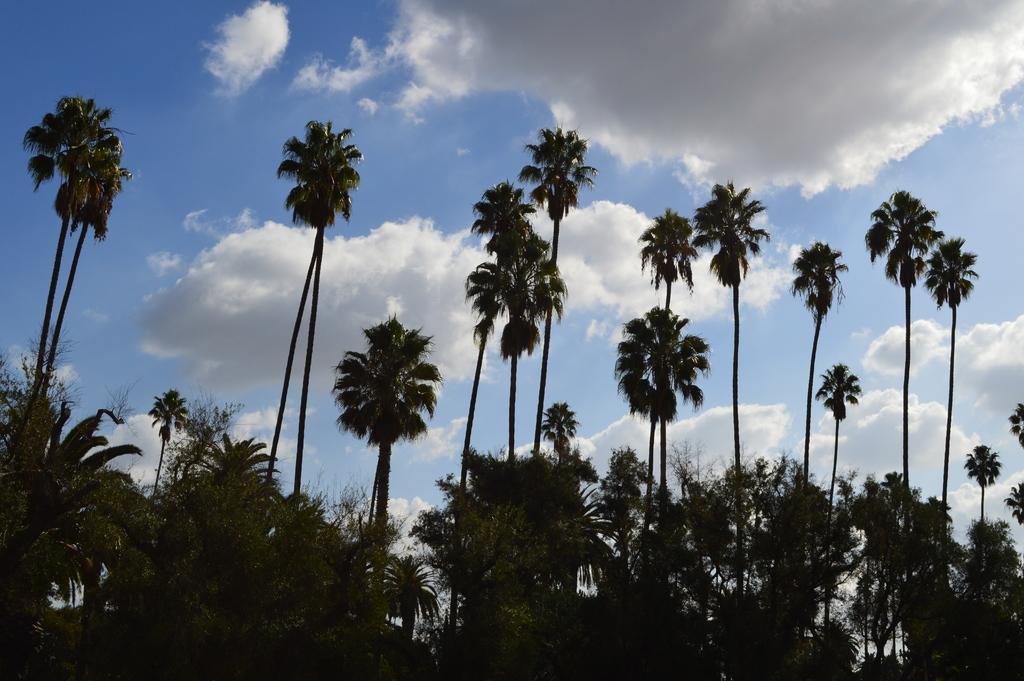Please provide a concise description of this image. Here we can see trees. In the background there is sky with clouds. 